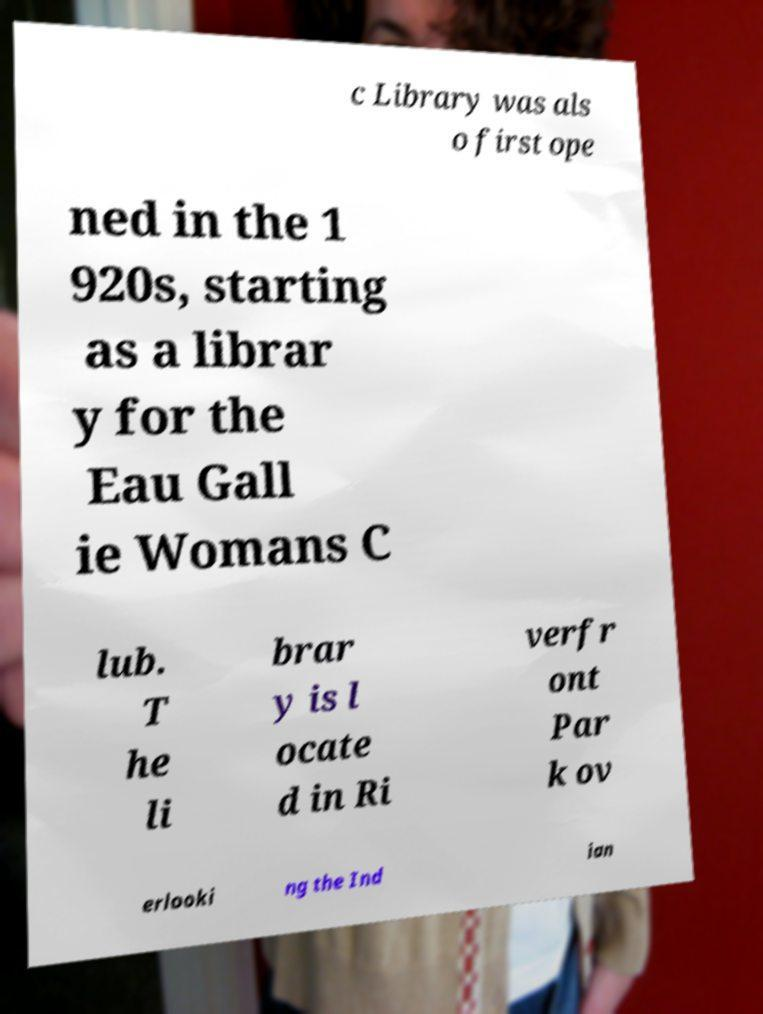Please identify and transcribe the text found in this image. c Library was als o first ope ned in the 1 920s, starting as a librar y for the Eau Gall ie Womans C lub. T he li brar y is l ocate d in Ri verfr ont Par k ov erlooki ng the Ind ian 